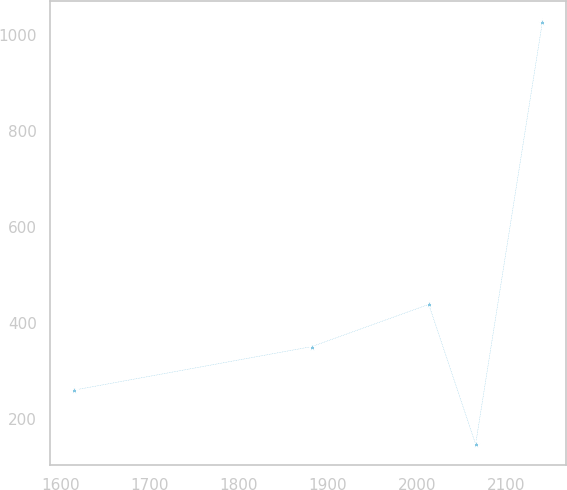Convert chart. <chart><loc_0><loc_0><loc_500><loc_500><line_chart><ecel><fcel>Unnamed: 1<nl><fcel>1615.07<fcel>259.19<nl><fcel>1882.11<fcel>350.06<nl><fcel>2013.36<fcel>438.05<nl><fcel>2065.93<fcel>146.4<nl><fcel>2140.75<fcel>1026.28<nl></chart> 